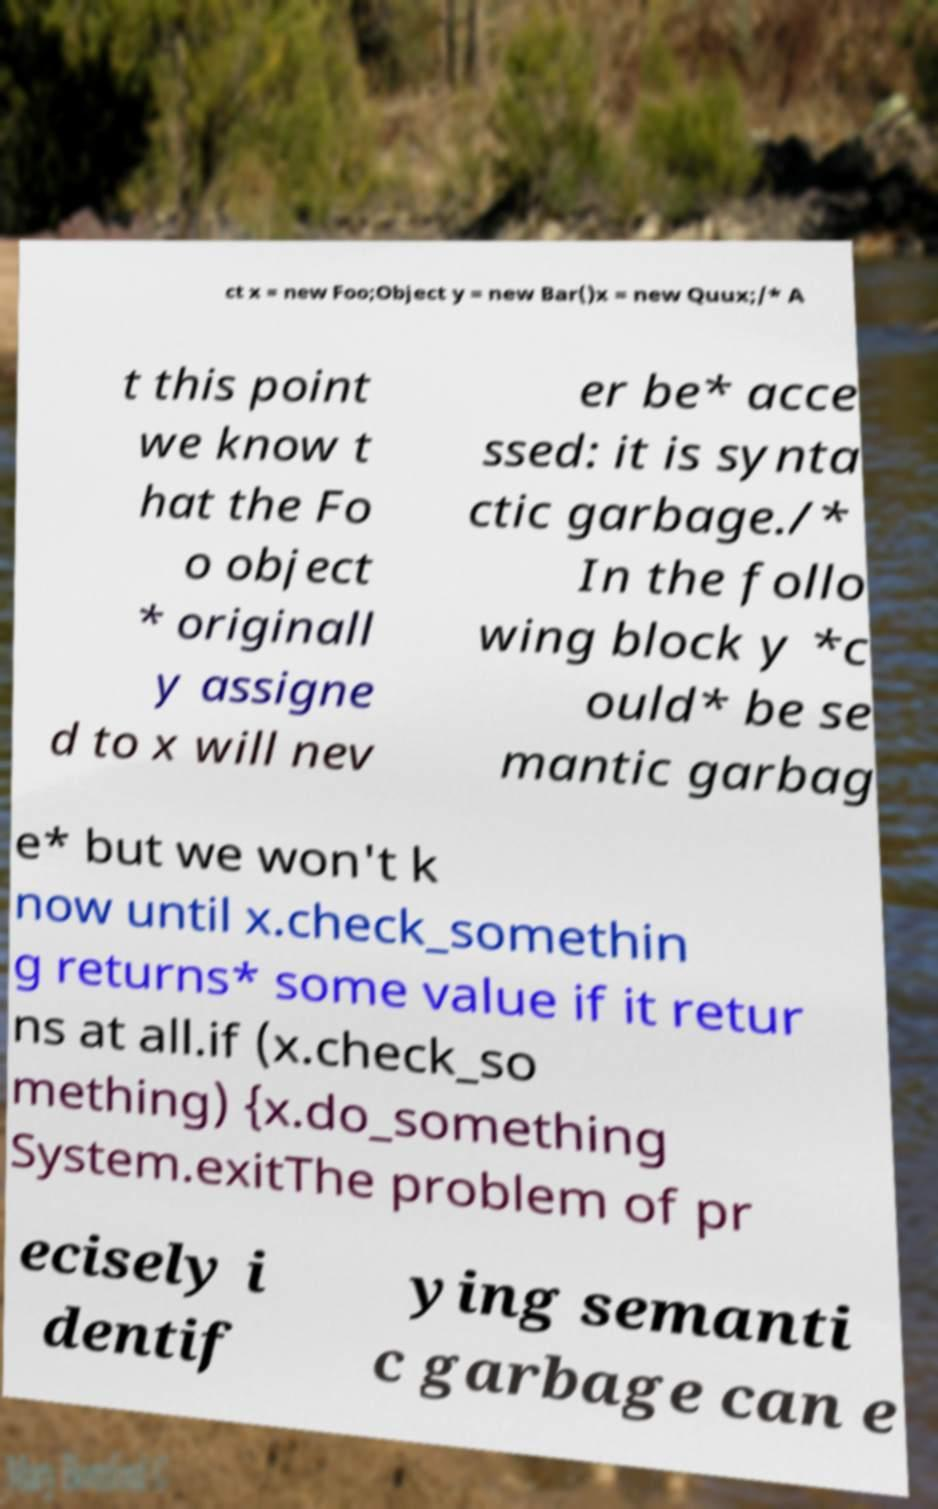Can you accurately transcribe the text from the provided image for me? ct x = new Foo;Object y = new Bar()x = new Quux;/* A t this point we know t hat the Fo o object * originall y assigne d to x will nev er be* acce ssed: it is synta ctic garbage./* In the follo wing block y *c ould* be se mantic garbag e* but we won't k now until x.check_somethin g returns* some value if it retur ns at all.if (x.check_so mething) {x.do_something System.exitThe problem of pr ecisely i dentif ying semanti c garbage can e 